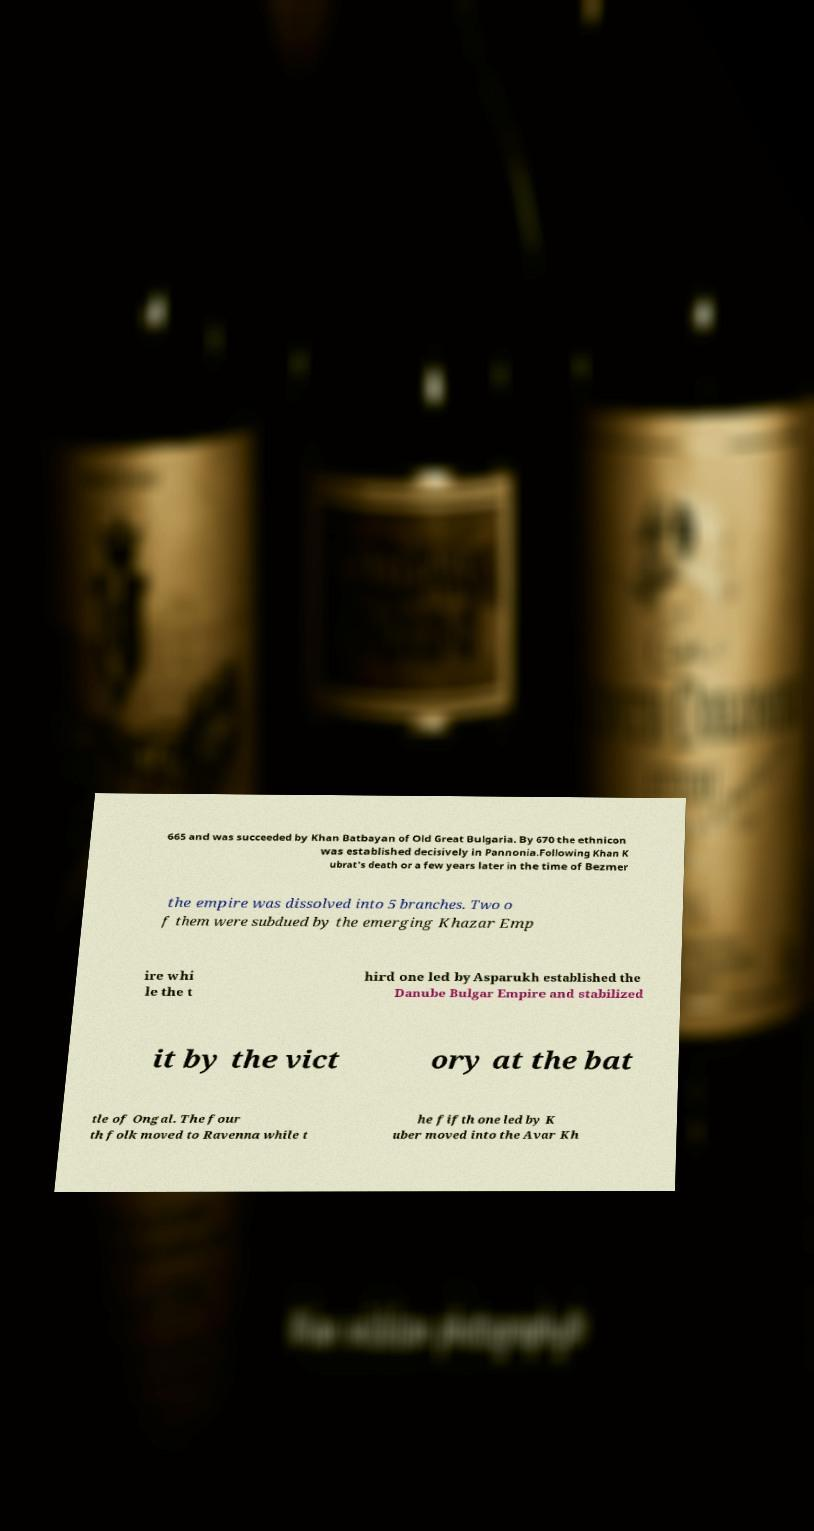I need the written content from this picture converted into text. Can you do that? 665 and was succeeded by Khan Batbayan of Old Great Bulgaria. By 670 the ethnicon was established decisively in Pannonia.Following Khan K ubrat's death or a few years later in the time of Bezmer the empire was dissolved into 5 branches. Two o f them were subdued by the emerging Khazar Emp ire whi le the t hird one led by Asparukh established the Danube Bulgar Empire and stabilized it by the vict ory at the bat tle of Ongal. The four th folk moved to Ravenna while t he fifth one led by K uber moved into the Avar Kh 